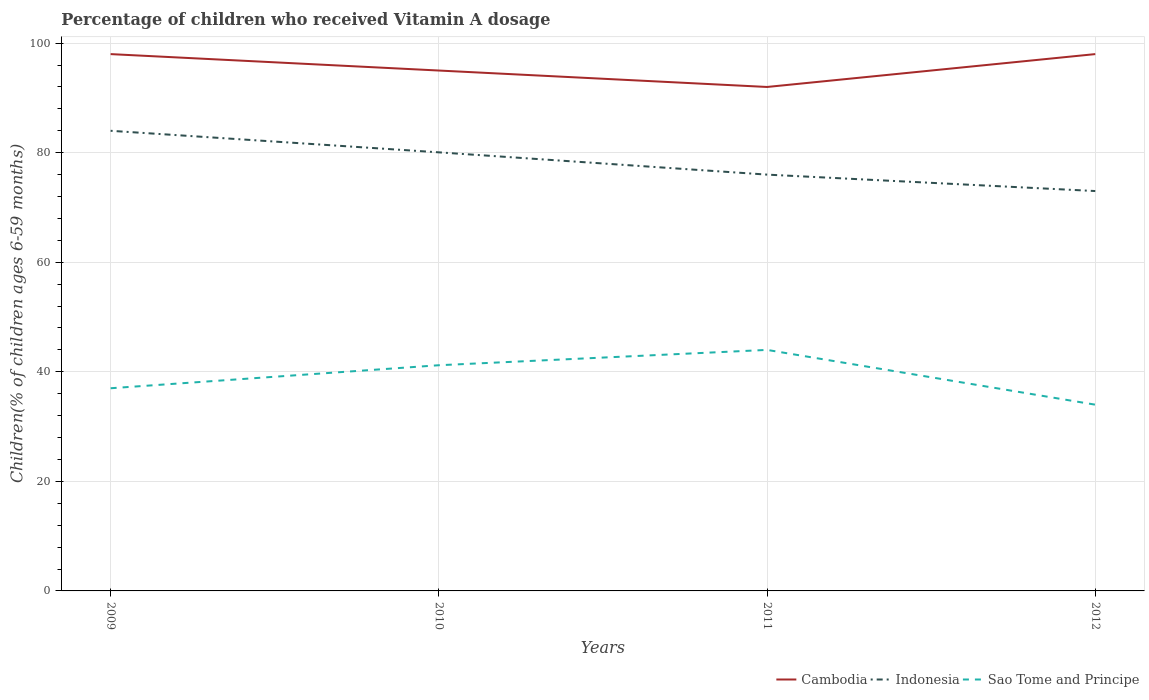How many different coloured lines are there?
Give a very brief answer. 3. Does the line corresponding to Sao Tome and Principe intersect with the line corresponding to Cambodia?
Offer a very short reply. No. Is the number of lines equal to the number of legend labels?
Ensure brevity in your answer.  Yes. Across all years, what is the maximum percentage of children who received Vitamin A dosage in Indonesia?
Offer a very short reply. 73. In which year was the percentage of children who received Vitamin A dosage in Sao Tome and Principe maximum?
Your answer should be compact. 2012. What is the difference between the highest and the second highest percentage of children who received Vitamin A dosage in Cambodia?
Keep it short and to the point. 6. What is the difference between two consecutive major ticks on the Y-axis?
Provide a succinct answer. 20. Are the values on the major ticks of Y-axis written in scientific E-notation?
Offer a very short reply. No. Does the graph contain any zero values?
Offer a terse response. No. Does the graph contain grids?
Give a very brief answer. Yes. Where does the legend appear in the graph?
Make the answer very short. Bottom right. What is the title of the graph?
Your answer should be compact. Percentage of children who received Vitamin A dosage. Does "Russian Federation" appear as one of the legend labels in the graph?
Ensure brevity in your answer.  No. What is the label or title of the Y-axis?
Your answer should be very brief. Children(% of children ages 6-59 months). What is the Children(% of children ages 6-59 months) in Cambodia in 2009?
Offer a very short reply. 98. What is the Children(% of children ages 6-59 months) in Indonesia in 2010?
Your response must be concise. 80.07. What is the Children(% of children ages 6-59 months) of Sao Tome and Principe in 2010?
Provide a short and direct response. 41.2. What is the Children(% of children ages 6-59 months) in Cambodia in 2011?
Your answer should be very brief. 92. What is the Children(% of children ages 6-59 months) of Cambodia in 2012?
Your answer should be compact. 98. What is the Children(% of children ages 6-59 months) in Indonesia in 2012?
Offer a terse response. 73. What is the Children(% of children ages 6-59 months) in Sao Tome and Principe in 2012?
Your answer should be very brief. 34. Across all years, what is the maximum Children(% of children ages 6-59 months) of Cambodia?
Offer a very short reply. 98. Across all years, what is the maximum Children(% of children ages 6-59 months) in Indonesia?
Provide a short and direct response. 84. Across all years, what is the minimum Children(% of children ages 6-59 months) of Cambodia?
Offer a very short reply. 92. Across all years, what is the minimum Children(% of children ages 6-59 months) of Indonesia?
Provide a succinct answer. 73. Across all years, what is the minimum Children(% of children ages 6-59 months) of Sao Tome and Principe?
Your answer should be compact. 34. What is the total Children(% of children ages 6-59 months) in Cambodia in the graph?
Offer a terse response. 383. What is the total Children(% of children ages 6-59 months) of Indonesia in the graph?
Offer a terse response. 313.07. What is the total Children(% of children ages 6-59 months) of Sao Tome and Principe in the graph?
Your answer should be very brief. 156.2. What is the difference between the Children(% of children ages 6-59 months) of Indonesia in 2009 and that in 2010?
Give a very brief answer. 3.93. What is the difference between the Children(% of children ages 6-59 months) in Sao Tome and Principe in 2009 and that in 2010?
Offer a terse response. -4.2. What is the difference between the Children(% of children ages 6-59 months) in Cambodia in 2009 and that in 2011?
Provide a succinct answer. 6. What is the difference between the Children(% of children ages 6-59 months) of Cambodia in 2009 and that in 2012?
Ensure brevity in your answer.  0. What is the difference between the Children(% of children ages 6-59 months) of Indonesia in 2009 and that in 2012?
Give a very brief answer. 11. What is the difference between the Children(% of children ages 6-59 months) in Indonesia in 2010 and that in 2011?
Provide a succinct answer. 4.07. What is the difference between the Children(% of children ages 6-59 months) of Sao Tome and Principe in 2010 and that in 2011?
Offer a terse response. -2.8. What is the difference between the Children(% of children ages 6-59 months) in Indonesia in 2010 and that in 2012?
Your answer should be very brief. 7.07. What is the difference between the Children(% of children ages 6-59 months) in Sao Tome and Principe in 2010 and that in 2012?
Give a very brief answer. 7.2. What is the difference between the Children(% of children ages 6-59 months) in Cambodia in 2011 and that in 2012?
Ensure brevity in your answer.  -6. What is the difference between the Children(% of children ages 6-59 months) in Cambodia in 2009 and the Children(% of children ages 6-59 months) in Indonesia in 2010?
Offer a terse response. 17.93. What is the difference between the Children(% of children ages 6-59 months) of Cambodia in 2009 and the Children(% of children ages 6-59 months) of Sao Tome and Principe in 2010?
Make the answer very short. 56.8. What is the difference between the Children(% of children ages 6-59 months) of Indonesia in 2009 and the Children(% of children ages 6-59 months) of Sao Tome and Principe in 2010?
Offer a very short reply. 42.8. What is the difference between the Children(% of children ages 6-59 months) of Cambodia in 2009 and the Children(% of children ages 6-59 months) of Indonesia in 2011?
Offer a terse response. 22. What is the difference between the Children(% of children ages 6-59 months) of Cambodia in 2009 and the Children(% of children ages 6-59 months) of Sao Tome and Principe in 2012?
Provide a succinct answer. 64. What is the difference between the Children(% of children ages 6-59 months) in Indonesia in 2009 and the Children(% of children ages 6-59 months) in Sao Tome and Principe in 2012?
Offer a very short reply. 50. What is the difference between the Children(% of children ages 6-59 months) in Cambodia in 2010 and the Children(% of children ages 6-59 months) in Sao Tome and Principe in 2011?
Your answer should be very brief. 51. What is the difference between the Children(% of children ages 6-59 months) of Indonesia in 2010 and the Children(% of children ages 6-59 months) of Sao Tome and Principe in 2011?
Offer a very short reply. 36.07. What is the difference between the Children(% of children ages 6-59 months) of Cambodia in 2010 and the Children(% of children ages 6-59 months) of Indonesia in 2012?
Offer a very short reply. 22. What is the difference between the Children(% of children ages 6-59 months) of Cambodia in 2010 and the Children(% of children ages 6-59 months) of Sao Tome and Principe in 2012?
Provide a succinct answer. 61. What is the difference between the Children(% of children ages 6-59 months) in Indonesia in 2010 and the Children(% of children ages 6-59 months) in Sao Tome and Principe in 2012?
Provide a succinct answer. 46.07. What is the difference between the Children(% of children ages 6-59 months) in Cambodia in 2011 and the Children(% of children ages 6-59 months) in Indonesia in 2012?
Offer a very short reply. 19. What is the average Children(% of children ages 6-59 months) of Cambodia per year?
Make the answer very short. 95.75. What is the average Children(% of children ages 6-59 months) in Indonesia per year?
Give a very brief answer. 78.27. What is the average Children(% of children ages 6-59 months) in Sao Tome and Principe per year?
Provide a short and direct response. 39.05. In the year 2009, what is the difference between the Children(% of children ages 6-59 months) in Cambodia and Children(% of children ages 6-59 months) in Indonesia?
Your answer should be compact. 14. In the year 2010, what is the difference between the Children(% of children ages 6-59 months) in Cambodia and Children(% of children ages 6-59 months) in Indonesia?
Make the answer very short. 14.93. In the year 2010, what is the difference between the Children(% of children ages 6-59 months) in Cambodia and Children(% of children ages 6-59 months) in Sao Tome and Principe?
Your answer should be compact. 53.8. In the year 2010, what is the difference between the Children(% of children ages 6-59 months) of Indonesia and Children(% of children ages 6-59 months) of Sao Tome and Principe?
Your answer should be very brief. 38.87. In the year 2012, what is the difference between the Children(% of children ages 6-59 months) in Cambodia and Children(% of children ages 6-59 months) in Sao Tome and Principe?
Offer a very short reply. 64. In the year 2012, what is the difference between the Children(% of children ages 6-59 months) of Indonesia and Children(% of children ages 6-59 months) of Sao Tome and Principe?
Give a very brief answer. 39. What is the ratio of the Children(% of children ages 6-59 months) in Cambodia in 2009 to that in 2010?
Keep it short and to the point. 1.03. What is the ratio of the Children(% of children ages 6-59 months) of Indonesia in 2009 to that in 2010?
Your response must be concise. 1.05. What is the ratio of the Children(% of children ages 6-59 months) in Sao Tome and Principe in 2009 to that in 2010?
Give a very brief answer. 0.9. What is the ratio of the Children(% of children ages 6-59 months) of Cambodia in 2009 to that in 2011?
Your answer should be very brief. 1.07. What is the ratio of the Children(% of children ages 6-59 months) of Indonesia in 2009 to that in 2011?
Ensure brevity in your answer.  1.11. What is the ratio of the Children(% of children ages 6-59 months) of Sao Tome and Principe in 2009 to that in 2011?
Keep it short and to the point. 0.84. What is the ratio of the Children(% of children ages 6-59 months) in Indonesia in 2009 to that in 2012?
Your answer should be very brief. 1.15. What is the ratio of the Children(% of children ages 6-59 months) in Sao Tome and Principe in 2009 to that in 2012?
Keep it short and to the point. 1.09. What is the ratio of the Children(% of children ages 6-59 months) of Cambodia in 2010 to that in 2011?
Provide a short and direct response. 1.03. What is the ratio of the Children(% of children ages 6-59 months) of Indonesia in 2010 to that in 2011?
Provide a succinct answer. 1.05. What is the ratio of the Children(% of children ages 6-59 months) of Sao Tome and Principe in 2010 to that in 2011?
Offer a very short reply. 0.94. What is the ratio of the Children(% of children ages 6-59 months) of Cambodia in 2010 to that in 2012?
Your answer should be very brief. 0.97. What is the ratio of the Children(% of children ages 6-59 months) of Indonesia in 2010 to that in 2012?
Offer a very short reply. 1.1. What is the ratio of the Children(% of children ages 6-59 months) in Sao Tome and Principe in 2010 to that in 2012?
Offer a terse response. 1.21. What is the ratio of the Children(% of children ages 6-59 months) of Cambodia in 2011 to that in 2012?
Provide a succinct answer. 0.94. What is the ratio of the Children(% of children ages 6-59 months) of Indonesia in 2011 to that in 2012?
Your answer should be compact. 1.04. What is the ratio of the Children(% of children ages 6-59 months) of Sao Tome and Principe in 2011 to that in 2012?
Your answer should be very brief. 1.29. What is the difference between the highest and the second highest Children(% of children ages 6-59 months) in Cambodia?
Give a very brief answer. 0. What is the difference between the highest and the second highest Children(% of children ages 6-59 months) in Indonesia?
Give a very brief answer. 3.93. What is the difference between the highest and the second highest Children(% of children ages 6-59 months) in Sao Tome and Principe?
Keep it short and to the point. 2.8. What is the difference between the highest and the lowest Children(% of children ages 6-59 months) in Indonesia?
Provide a short and direct response. 11. 